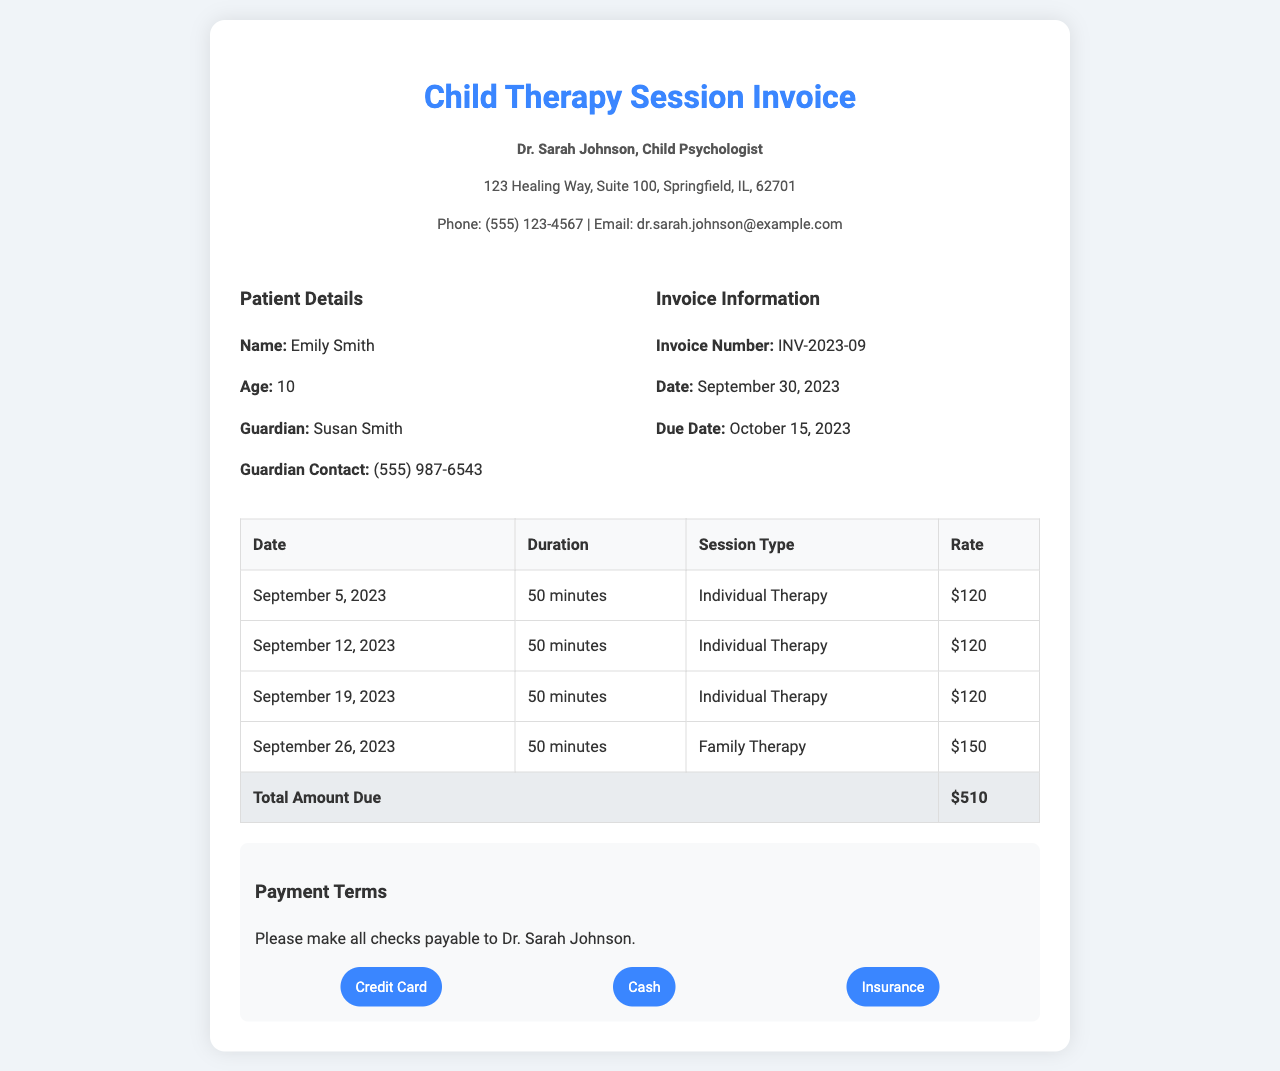What is the name of the child? The document provides the patient's name under 'Patient Details', which is Emily Smith.
Answer: Emily Smith What is the date of the invoice? The invoice date can be found in the 'Invoice Information' section, indicating it is September 30, 2023.
Answer: September 30, 2023 How many individual therapy sessions were provided? By counting the entries in the table for 'Individual Therapy', there are three sessions listed.
Answer: 3 What is the total amount due? The total amount is summarized in the table under 'Total Amount Due', which states $510.
Answer: $510 Which session type has the highest rate? The rates for the sessions are listed in the table; 'Family Therapy' has the highest rate at $150.
Answer: Family Therapy When is the due date for payment? The due date is specified in the 'Invoice Information' section as October 15, 2023.
Answer: October 15, 2023 What is the duration of each therapy session? The duration for each session is mentioned in the table and indicates a standard duration of 50 minutes.
Answer: 50 minutes Who is the guardian of the patient? The guardian's name is provided in the 'Patient Details' section, listed as Susan Smith.
Answer: Susan Smith What payment methods are accepted? The payment methods are listed in the 'Payment Terms' section as Credit Card, Cash, and Insurance.
Answer: Credit Card, Cash, Insurance 